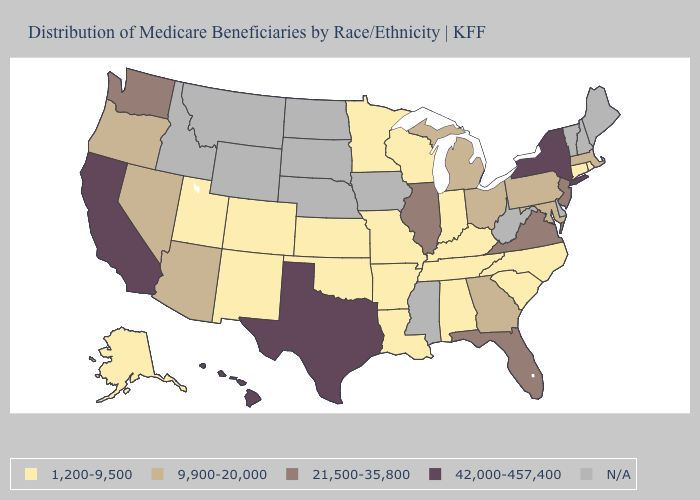Which states have the lowest value in the West?
Give a very brief answer. Alaska, Colorado, New Mexico, Utah. Which states have the highest value in the USA?
Quick response, please. California, Hawaii, New York, Texas. What is the value of Alabama?
Give a very brief answer. 1,200-9,500. Name the states that have a value in the range 9,900-20,000?
Short answer required. Arizona, Georgia, Maryland, Massachusetts, Michigan, Nevada, Ohio, Oregon, Pennsylvania. Name the states that have a value in the range 9,900-20,000?
Write a very short answer. Arizona, Georgia, Maryland, Massachusetts, Michigan, Nevada, Ohio, Oregon, Pennsylvania. What is the value of Idaho?
Quick response, please. N/A. Name the states that have a value in the range N/A?
Give a very brief answer. Delaware, Idaho, Iowa, Maine, Mississippi, Montana, Nebraska, New Hampshire, North Dakota, South Dakota, Vermont, West Virginia, Wyoming. What is the value of Vermont?
Keep it brief. N/A. What is the highest value in the MidWest ?
Quick response, please. 21,500-35,800. Name the states that have a value in the range 1,200-9,500?
Answer briefly. Alabama, Alaska, Arkansas, Colorado, Connecticut, Indiana, Kansas, Kentucky, Louisiana, Minnesota, Missouri, New Mexico, North Carolina, Oklahoma, Rhode Island, South Carolina, Tennessee, Utah, Wisconsin. Name the states that have a value in the range 1,200-9,500?
Keep it brief. Alabama, Alaska, Arkansas, Colorado, Connecticut, Indiana, Kansas, Kentucky, Louisiana, Minnesota, Missouri, New Mexico, North Carolina, Oklahoma, Rhode Island, South Carolina, Tennessee, Utah, Wisconsin. What is the value of Kentucky?
Give a very brief answer. 1,200-9,500. What is the highest value in the Northeast ?
Concise answer only. 42,000-457,400. 